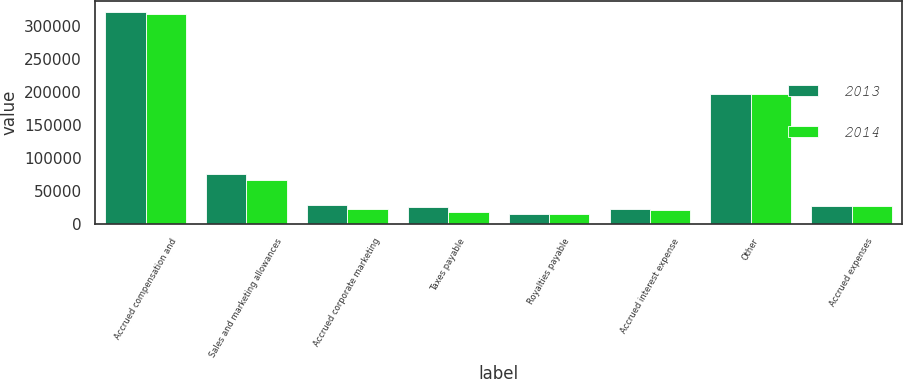Convert chart to OTSL. <chart><loc_0><loc_0><loc_500><loc_500><stacked_bar_chart><ecel><fcel>Accrued compensation and<fcel>Sales and marketing allowances<fcel>Accrued corporate marketing<fcel>Taxes payable<fcel>Royalties payable<fcel>Accrued interest expense<fcel>Other<fcel>Accrued expenses<nl><fcel>2013<fcel>320679<fcel>75627<fcel>28369<fcel>24658<fcel>15073<fcel>22621<fcel>196839<fcel>26513.5<nl><fcel>2014<fcel>318219<fcel>66502<fcel>22801<fcel>18225<fcel>14778<fcel>20613<fcel>195801<fcel>26513.5<nl></chart> 